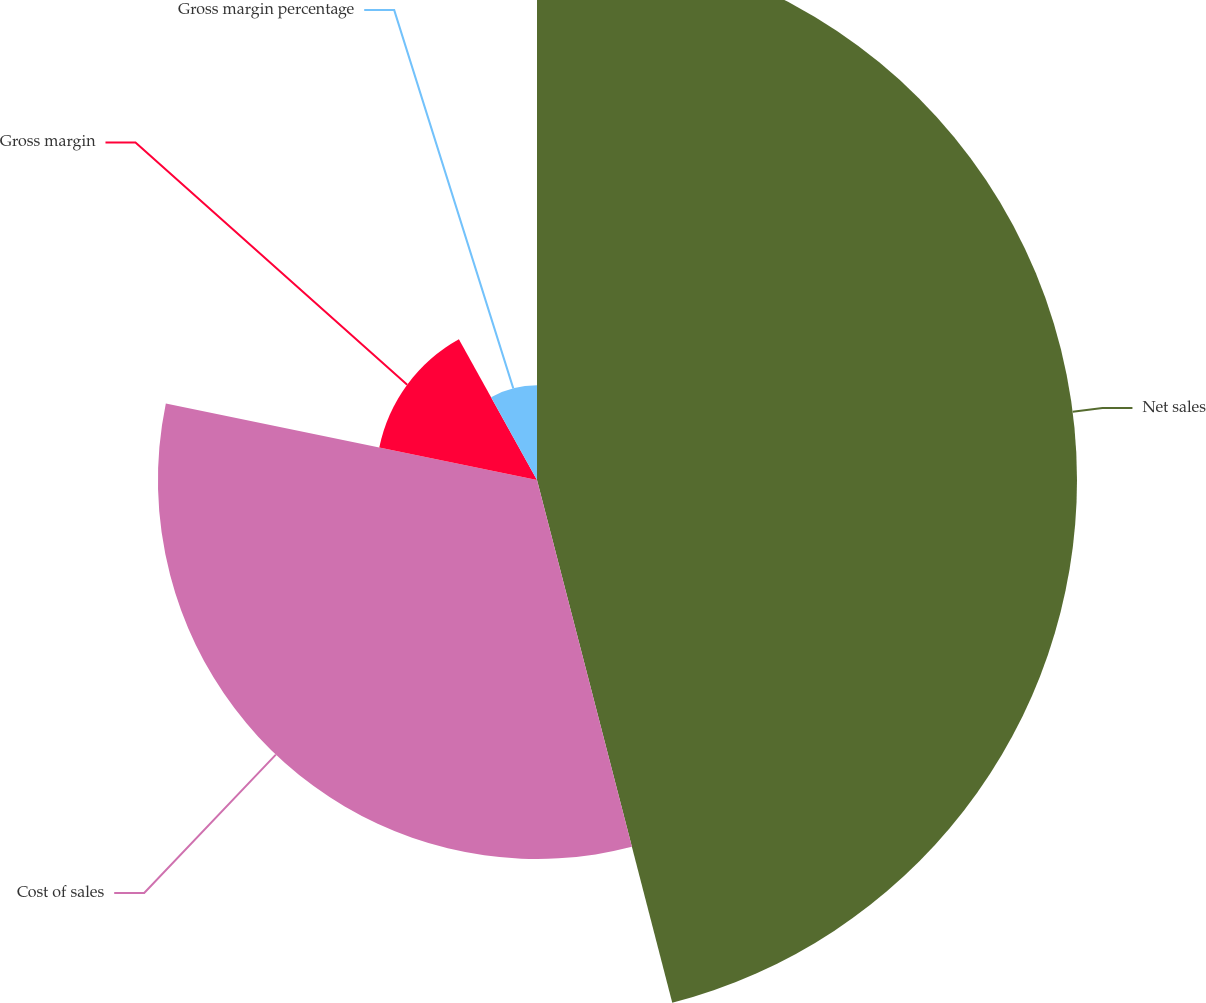Convert chart to OTSL. <chart><loc_0><loc_0><loc_500><loc_500><pie_chart><fcel>Net sales<fcel>Cost of sales<fcel>Gross margin<fcel>Gross margin percentage<nl><fcel>45.97%<fcel>32.26%<fcel>13.71%<fcel>8.06%<nl></chart> 